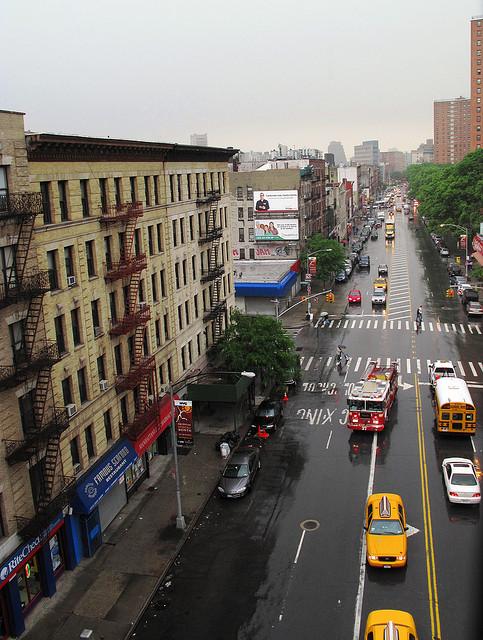Can you see a fire?
Give a very brief answer. No. How many fire escapes do you see?
Concise answer only. 3. Where is the fire engine?
Write a very short answer. Middle. 